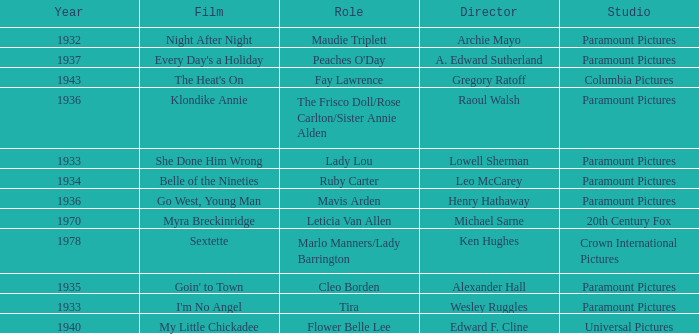What is the Year of the Film Klondike Annie? 1936.0. 